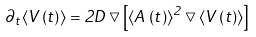Convert formula to latex. <formula><loc_0><loc_0><loc_500><loc_500>\partial _ { t } \langle V \left ( t \right ) \rangle = 2 D \bigtriangledown \left [ \langle A \left ( t \right ) \rangle ^ { 2 } \bigtriangledown \langle V \left ( t \right ) \rangle \right ]</formula> 